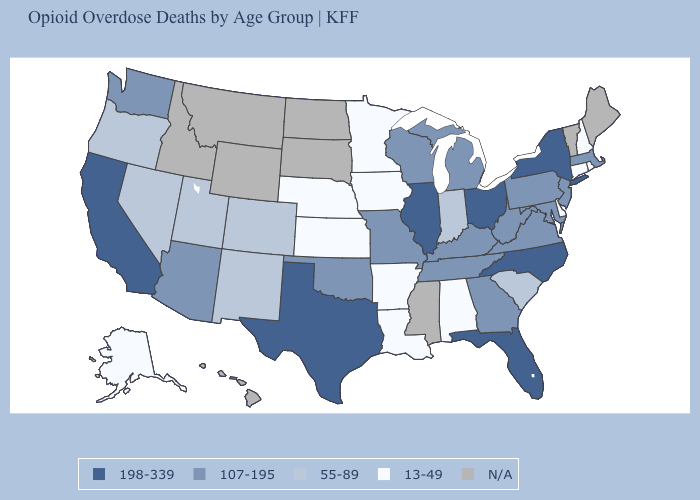What is the value of Missouri?
Be succinct. 107-195. Among the states that border Pennsylvania , does New York have the highest value?
Quick response, please. Yes. Name the states that have a value in the range N/A?
Give a very brief answer. Hawaii, Idaho, Maine, Mississippi, Montana, North Dakota, South Dakota, Vermont, Wyoming. Name the states that have a value in the range N/A?
Keep it brief. Hawaii, Idaho, Maine, Mississippi, Montana, North Dakota, South Dakota, Vermont, Wyoming. What is the value of Idaho?
Answer briefly. N/A. Among the states that border Connecticut , which have the highest value?
Keep it brief. New York. Name the states that have a value in the range 13-49?
Concise answer only. Alabama, Alaska, Arkansas, Connecticut, Delaware, Iowa, Kansas, Louisiana, Minnesota, Nebraska, New Hampshire, Rhode Island. What is the highest value in the South ?
Give a very brief answer. 198-339. Among the states that border Maryland , which have the highest value?
Keep it brief. Pennsylvania, Virginia, West Virginia. Name the states that have a value in the range 198-339?
Write a very short answer. California, Florida, Illinois, New York, North Carolina, Ohio, Texas. Name the states that have a value in the range N/A?
Give a very brief answer. Hawaii, Idaho, Maine, Mississippi, Montana, North Dakota, South Dakota, Vermont, Wyoming. What is the value of Florida?
Keep it brief. 198-339. How many symbols are there in the legend?
Be succinct. 5. 